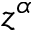<formula> <loc_0><loc_0><loc_500><loc_500>z ^ { \alpha }</formula> 